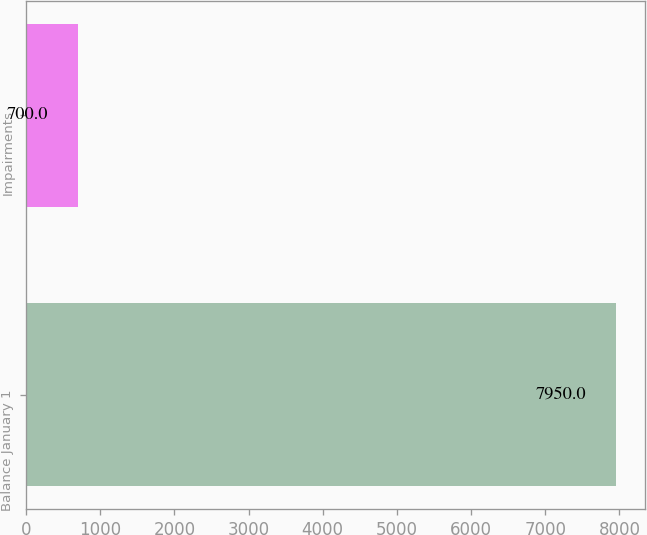<chart> <loc_0><loc_0><loc_500><loc_500><bar_chart><fcel>Balance January 1<fcel>Impairments<nl><fcel>7950<fcel>700<nl></chart> 